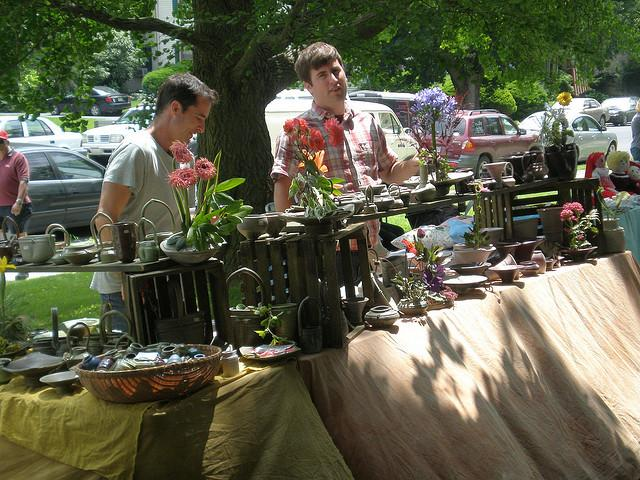What items are being shown off most frequently here? planters 